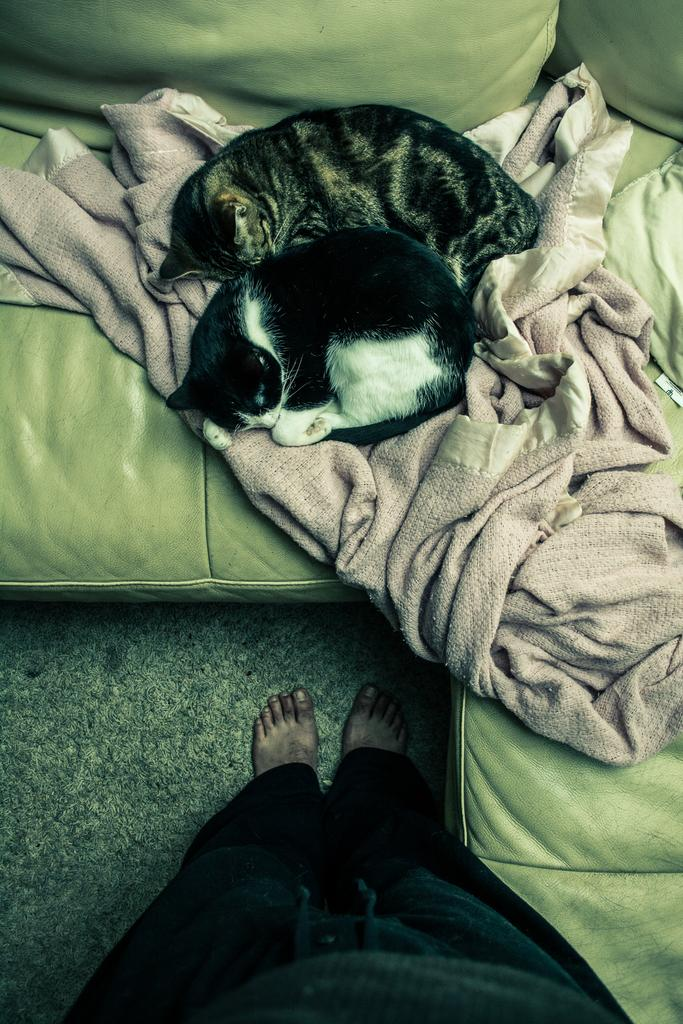What is the main piece of furniture in the image? There is a couch in the center of the image. What is covering the couch? There is a blanket on the couch. What animals are lying on the couch? There are two cats lying on the couch. Can you describe the person visible in the image? There is a person visible at the bottom of the image. What type of arch can be seen in the background of the image? There is no arch visible in the background of the image. 